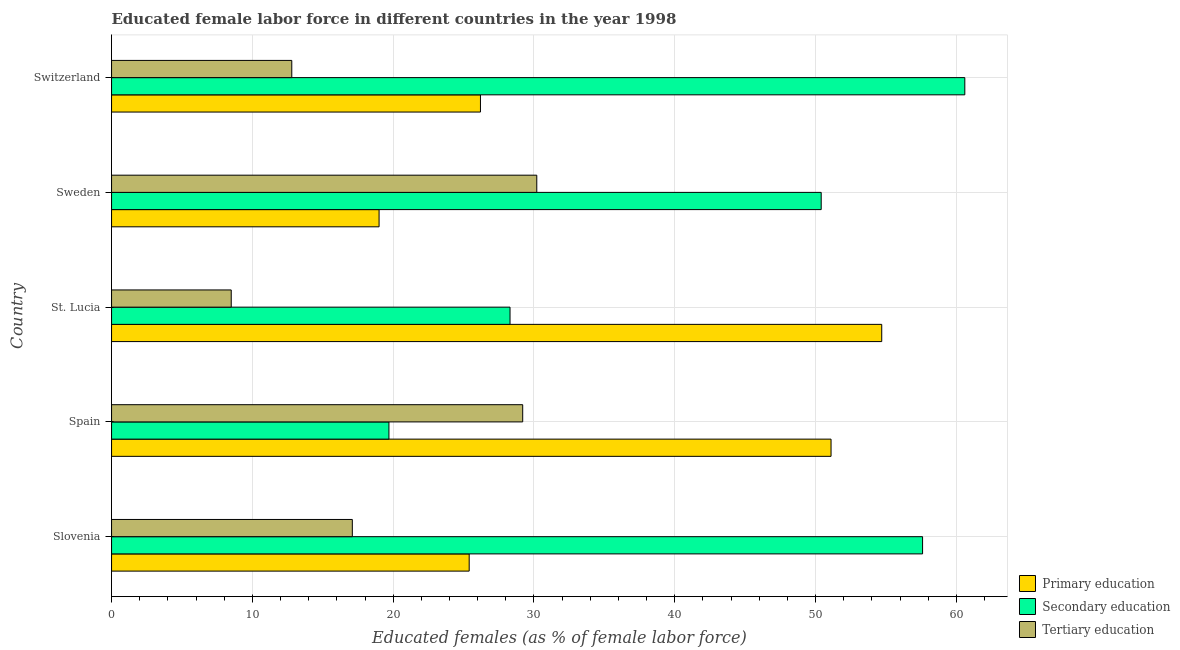How many different coloured bars are there?
Keep it short and to the point. 3. How many groups of bars are there?
Give a very brief answer. 5. Are the number of bars per tick equal to the number of legend labels?
Give a very brief answer. Yes. How many bars are there on the 5th tick from the top?
Your answer should be compact. 3. What is the label of the 3rd group of bars from the top?
Provide a short and direct response. St. Lucia. What is the percentage of female labor force who received primary education in St. Lucia?
Offer a very short reply. 54.7. Across all countries, what is the maximum percentage of female labor force who received secondary education?
Make the answer very short. 60.6. Across all countries, what is the minimum percentage of female labor force who received primary education?
Your response must be concise. 19. In which country was the percentage of female labor force who received primary education maximum?
Provide a short and direct response. St. Lucia. In which country was the percentage of female labor force who received secondary education minimum?
Provide a succinct answer. Spain. What is the total percentage of female labor force who received tertiary education in the graph?
Provide a succinct answer. 97.8. What is the difference between the percentage of female labor force who received secondary education in Sweden and that in Switzerland?
Ensure brevity in your answer.  -10.2. What is the difference between the percentage of female labor force who received primary education in Sweden and the percentage of female labor force who received secondary education in Switzerland?
Make the answer very short. -41.6. What is the average percentage of female labor force who received secondary education per country?
Your answer should be very brief. 43.32. What is the difference between the percentage of female labor force who received secondary education and percentage of female labor force who received primary education in Sweden?
Give a very brief answer. 31.4. In how many countries, is the percentage of female labor force who received tertiary education greater than 56 %?
Your answer should be very brief. 0. What is the ratio of the percentage of female labor force who received primary education in St. Lucia to that in Sweden?
Offer a terse response. 2.88. Is the difference between the percentage of female labor force who received tertiary education in Spain and Switzerland greater than the difference between the percentage of female labor force who received secondary education in Spain and Switzerland?
Provide a short and direct response. Yes. What is the difference between the highest and the lowest percentage of female labor force who received primary education?
Give a very brief answer. 35.7. In how many countries, is the percentage of female labor force who received tertiary education greater than the average percentage of female labor force who received tertiary education taken over all countries?
Keep it short and to the point. 2. Is the sum of the percentage of female labor force who received tertiary education in Spain and St. Lucia greater than the maximum percentage of female labor force who received secondary education across all countries?
Ensure brevity in your answer.  No. What does the 2nd bar from the bottom in Switzerland represents?
Give a very brief answer. Secondary education. Is it the case that in every country, the sum of the percentage of female labor force who received primary education and percentage of female labor force who received secondary education is greater than the percentage of female labor force who received tertiary education?
Provide a short and direct response. Yes. Are all the bars in the graph horizontal?
Provide a succinct answer. Yes. How many countries are there in the graph?
Give a very brief answer. 5. How are the legend labels stacked?
Provide a succinct answer. Vertical. What is the title of the graph?
Ensure brevity in your answer.  Educated female labor force in different countries in the year 1998. What is the label or title of the X-axis?
Your answer should be very brief. Educated females (as % of female labor force). What is the Educated females (as % of female labor force) in Primary education in Slovenia?
Your answer should be very brief. 25.4. What is the Educated females (as % of female labor force) of Secondary education in Slovenia?
Provide a short and direct response. 57.6. What is the Educated females (as % of female labor force) in Tertiary education in Slovenia?
Your answer should be compact. 17.1. What is the Educated females (as % of female labor force) of Primary education in Spain?
Offer a terse response. 51.1. What is the Educated females (as % of female labor force) of Secondary education in Spain?
Your answer should be compact. 19.7. What is the Educated females (as % of female labor force) in Tertiary education in Spain?
Keep it short and to the point. 29.2. What is the Educated females (as % of female labor force) of Primary education in St. Lucia?
Make the answer very short. 54.7. What is the Educated females (as % of female labor force) in Secondary education in St. Lucia?
Make the answer very short. 28.3. What is the Educated females (as % of female labor force) in Tertiary education in St. Lucia?
Ensure brevity in your answer.  8.5. What is the Educated females (as % of female labor force) in Secondary education in Sweden?
Offer a very short reply. 50.4. What is the Educated females (as % of female labor force) of Tertiary education in Sweden?
Keep it short and to the point. 30.2. What is the Educated females (as % of female labor force) of Primary education in Switzerland?
Your response must be concise. 26.2. What is the Educated females (as % of female labor force) of Secondary education in Switzerland?
Ensure brevity in your answer.  60.6. What is the Educated females (as % of female labor force) in Tertiary education in Switzerland?
Ensure brevity in your answer.  12.8. Across all countries, what is the maximum Educated females (as % of female labor force) of Primary education?
Provide a succinct answer. 54.7. Across all countries, what is the maximum Educated females (as % of female labor force) in Secondary education?
Your answer should be compact. 60.6. Across all countries, what is the maximum Educated females (as % of female labor force) of Tertiary education?
Give a very brief answer. 30.2. Across all countries, what is the minimum Educated females (as % of female labor force) in Primary education?
Your answer should be compact. 19. Across all countries, what is the minimum Educated females (as % of female labor force) of Secondary education?
Make the answer very short. 19.7. Across all countries, what is the minimum Educated females (as % of female labor force) of Tertiary education?
Keep it short and to the point. 8.5. What is the total Educated females (as % of female labor force) in Primary education in the graph?
Your answer should be very brief. 176.4. What is the total Educated females (as % of female labor force) in Secondary education in the graph?
Make the answer very short. 216.6. What is the total Educated females (as % of female labor force) in Tertiary education in the graph?
Offer a very short reply. 97.8. What is the difference between the Educated females (as % of female labor force) in Primary education in Slovenia and that in Spain?
Offer a very short reply. -25.7. What is the difference between the Educated females (as % of female labor force) of Secondary education in Slovenia and that in Spain?
Offer a very short reply. 37.9. What is the difference between the Educated females (as % of female labor force) of Tertiary education in Slovenia and that in Spain?
Offer a very short reply. -12.1. What is the difference between the Educated females (as % of female labor force) of Primary education in Slovenia and that in St. Lucia?
Your answer should be compact. -29.3. What is the difference between the Educated females (as % of female labor force) of Secondary education in Slovenia and that in St. Lucia?
Offer a terse response. 29.3. What is the difference between the Educated females (as % of female labor force) of Primary education in Slovenia and that in Sweden?
Keep it short and to the point. 6.4. What is the difference between the Educated females (as % of female labor force) of Tertiary education in Slovenia and that in Sweden?
Keep it short and to the point. -13.1. What is the difference between the Educated females (as % of female labor force) in Primary education in Slovenia and that in Switzerland?
Make the answer very short. -0.8. What is the difference between the Educated females (as % of female labor force) of Tertiary education in Slovenia and that in Switzerland?
Offer a very short reply. 4.3. What is the difference between the Educated females (as % of female labor force) in Primary education in Spain and that in St. Lucia?
Provide a succinct answer. -3.6. What is the difference between the Educated females (as % of female labor force) of Secondary education in Spain and that in St. Lucia?
Offer a very short reply. -8.6. What is the difference between the Educated females (as % of female labor force) of Tertiary education in Spain and that in St. Lucia?
Your response must be concise. 20.7. What is the difference between the Educated females (as % of female labor force) of Primary education in Spain and that in Sweden?
Offer a terse response. 32.1. What is the difference between the Educated females (as % of female labor force) of Secondary education in Spain and that in Sweden?
Your answer should be compact. -30.7. What is the difference between the Educated females (as % of female labor force) of Tertiary education in Spain and that in Sweden?
Keep it short and to the point. -1. What is the difference between the Educated females (as % of female labor force) of Primary education in Spain and that in Switzerland?
Ensure brevity in your answer.  24.9. What is the difference between the Educated females (as % of female labor force) in Secondary education in Spain and that in Switzerland?
Offer a terse response. -40.9. What is the difference between the Educated females (as % of female labor force) in Primary education in St. Lucia and that in Sweden?
Offer a very short reply. 35.7. What is the difference between the Educated females (as % of female labor force) in Secondary education in St. Lucia and that in Sweden?
Ensure brevity in your answer.  -22.1. What is the difference between the Educated females (as % of female labor force) in Tertiary education in St. Lucia and that in Sweden?
Give a very brief answer. -21.7. What is the difference between the Educated females (as % of female labor force) in Secondary education in St. Lucia and that in Switzerland?
Provide a succinct answer. -32.3. What is the difference between the Educated females (as % of female labor force) in Tertiary education in Sweden and that in Switzerland?
Ensure brevity in your answer.  17.4. What is the difference between the Educated females (as % of female labor force) of Secondary education in Slovenia and the Educated females (as % of female labor force) of Tertiary education in Spain?
Your answer should be compact. 28.4. What is the difference between the Educated females (as % of female labor force) in Secondary education in Slovenia and the Educated females (as % of female labor force) in Tertiary education in St. Lucia?
Your answer should be very brief. 49.1. What is the difference between the Educated females (as % of female labor force) of Secondary education in Slovenia and the Educated females (as % of female labor force) of Tertiary education in Sweden?
Provide a short and direct response. 27.4. What is the difference between the Educated females (as % of female labor force) in Primary education in Slovenia and the Educated females (as % of female labor force) in Secondary education in Switzerland?
Ensure brevity in your answer.  -35.2. What is the difference between the Educated females (as % of female labor force) in Secondary education in Slovenia and the Educated females (as % of female labor force) in Tertiary education in Switzerland?
Your answer should be very brief. 44.8. What is the difference between the Educated females (as % of female labor force) in Primary education in Spain and the Educated females (as % of female labor force) in Secondary education in St. Lucia?
Make the answer very short. 22.8. What is the difference between the Educated females (as % of female labor force) of Primary education in Spain and the Educated females (as % of female labor force) of Tertiary education in St. Lucia?
Give a very brief answer. 42.6. What is the difference between the Educated females (as % of female labor force) in Secondary education in Spain and the Educated females (as % of female labor force) in Tertiary education in St. Lucia?
Your answer should be compact. 11.2. What is the difference between the Educated females (as % of female labor force) in Primary education in Spain and the Educated females (as % of female labor force) in Secondary education in Sweden?
Your answer should be very brief. 0.7. What is the difference between the Educated females (as % of female labor force) in Primary education in Spain and the Educated females (as % of female labor force) in Tertiary education in Sweden?
Keep it short and to the point. 20.9. What is the difference between the Educated females (as % of female labor force) of Primary education in Spain and the Educated females (as % of female labor force) of Tertiary education in Switzerland?
Keep it short and to the point. 38.3. What is the difference between the Educated females (as % of female labor force) of Primary education in St. Lucia and the Educated females (as % of female labor force) of Secondary education in Sweden?
Offer a very short reply. 4.3. What is the difference between the Educated females (as % of female labor force) in Primary education in St. Lucia and the Educated females (as % of female labor force) in Secondary education in Switzerland?
Your answer should be compact. -5.9. What is the difference between the Educated females (as % of female labor force) of Primary education in St. Lucia and the Educated females (as % of female labor force) of Tertiary education in Switzerland?
Offer a very short reply. 41.9. What is the difference between the Educated females (as % of female labor force) of Secondary education in St. Lucia and the Educated females (as % of female labor force) of Tertiary education in Switzerland?
Your answer should be compact. 15.5. What is the difference between the Educated females (as % of female labor force) of Primary education in Sweden and the Educated females (as % of female labor force) of Secondary education in Switzerland?
Your response must be concise. -41.6. What is the difference between the Educated females (as % of female labor force) of Primary education in Sweden and the Educated females (as % of female labor force) of Tertiary education in Switzerland?
Your response must be concise. 6.2. What is the difference between the Educated females (as % of female labor force) of Secondary education in Sweden and the Educated females (as % of female labor force) of Tertiary education in Switzerland?
Your answer should be very brief. 37.6. What is the average Educated females (as % of female labor force) of Primary education per country?
Give a very brief answer. 35.28. What is the average Educated females (as % of female labor force) in Secondary education per country?
Give a very brief answer. 43.32. What is the average Educated females (as % of female labor force) of Tertiary education per country?
Your response must be concise. 19.56. What is the difference between the Educated females (as % of female labor force) in Primary education and Educated females (as % of female labor force) in Secondary education in Slovenia?
Ensure brevity in your answer.  -32.2. What is the difference between the Educated females (as % of female labor force) in Secondary education and Educated females (as % of female labor force) in Tertiary education in Slovenia?
Your answer should be compact. 40.5. What is the difference between the Educated females (as % of female labor force) of Primary education and Educated females (as % of female labor force) of Secondary education in Spain?
Your answer should be compact. 31.4. What is the difference between the Educated females (as % of female labor force) of Primary education and Educated females (as % of female labor force) of Tertiary education in Spain?
Make the answer very short. 21.9. What is the difference between the Educated females (as % of female labor force) of Secondary education and Educated females (as % of female labor force) of Tertiary education in Spain?
Ensure brevity in your answer.  -9.5. What is the difference between the Educated females (as % of female labor force) in Primary education and Educated females (as % of female labor force) in Secondary education in St. Lucia?
Your answer should be very brief. 26.4. What is the difference between the Educated females (as % of female labor force) in Primary education and Educated females (as % of female labor force) in Tertiary education in St. Lucia?
Provide a short and direct response. 46.2. What is the difference between the Educated females (as % of female labor force) in Secondary education and Educated females (as % of female labor force) in Tertiary education in St. Lucia?
Offer a terse response. 19.8. What is the difference between the Educated females (as % of female labor force) of Primary education and Educated females (as % of female labor force) of Secondary education in Sweden?
Your answer should be compact. -31.4. What is the difference between the Educated females (as % of female labor force) in Secondary education and Educated females (as % of female labor force) in Tertiary education in Sweden?
Give a very brief answer. 20.2. What is the difference between the Educated females (as % of female labor force) of Primary education and Educated females (as % of female labor force) of Secondary education in Switzerland?
Your answer should be very brief. -34.4. What is the difference between the Educated females (as % of female labor force) in Primary education and Educated females (as % of female labor force) in Tertiary education in Switzerland?
Your answer should be very brief. 13.4. What is the difference between the Educated females (as % of female labor force) in Secondary education and Educated females (as % of female labor force) in Tertiary education in Switzerland?
Your response must be concise. 47.8. What is the ratio of the Educated females (as % of female labor force) of Primary education in Slovenia to that in Spain?
Provide a short and direct response. 0.5. What is the ratio of the Educated females (as % of female labor force) in Secondary education in Slovenia to that in Spain?
Make the answer very short. 2.92. What is the ratio of the Educated females (as % of female labor force) in Tertiary education in Slovenia to that in Spain?
Provide a succinct answer. 0.59. What is the ratio of the Educated females (as % of female labor force) in Primary education in Slovenia to that in St. Lucia?
Offer a very short reply. 0.46. What is the ratio of the Educated females (as % of female labor force) of Secondary education in Slovenia to that in St. Lucia?
Ensure brevity in your answer.  2.04. What is the ratio of the Educated females (as % of female labor force) of Tertiary education in Slovenia to that in St. Lucia?
Provide a succinct answer. 2.01. What is the ratio of the Educated females (as % of female labor force) in Primary education in Slovenia to that in Sweden?
Provide a succinct answer. 1.34. What is the ratio of the Educated females (as % of female labor force) in Tertiary education in Slovenia to that in Sweden?
Offer a terse response. 0.57. What is the ratio of the Educated females (as % of female labor force) in Primary education in Slovenia to that in Switzerland?
Make the answer very short. 0.97. What is the ratio of the Educated females (as % of female labor force) in Secondary education in Slovenia to that in Switzerland?
Keep it short and to the point. 0.95. What is the ratio of the Educated females (as % of female labor force) in Tertiary education in Slovenia to that in Switzerland?
Give a very brief answer. 1.34. What is the ratio of the Educated females (as % of female labor force) of Primary education in Spain to that in St. Lucia?
Your answer should be compact. 0.93. What is the ratio of the Educated females (as % of female labor force) of Secondary education in Spain to that in St. Lucia?
Give a very brief answer. 0.7. What is the ratio of the Educated females (as % of female labor force) of Tertiary education in Spain to that in St. Lucia?
Your answer should be compact. 3.44. What is the ratio of the Educated females (as % of female labor force) of Primary education in Spain to that in Sweden?
Your answer should be compact. 2.69. What is the ratio of the Educated females (as % of female labor force) of Secondary education in Spain to that in Sweden?
Your answer should be compact. 0.39. What is the ratio of the Educated females (as % of female labor force) in Tertiary education in Spain to that in Sweden?
Offer a very short reply. 0.97. What is the ratio of the Educated females (as % of female labor force) in Primary education in Spain to that in Switzerland?
Offer a very short reply. 1.95. What is the ratio of the Educated females (as % of female labor force) of Secondary education in Spain to that in Switzerland?
Offer a terse response. 0.33. What is the ratio of the Educated females (as % of female labor force) in Tertiary education in Spain to that in Switzerland?
Make the answer very short. 2.28. What is the ratio of the Educated females (as % of female labor force) of Primary education in St. Lucia to that in Sweden?
Your answer should be compact. 2.88. What is the ratio of the Educated females (as % of female labor force) of Secondary education in St. Lucia to that in Sweden?
Provide a succinct answer. 0.56. What is the ratio of the Educated females (as % of female labor force) in Tertiary education in St. Lucia to that in Sweden?
Give a very brief answer. 0.28. What is the ratio of the Educated females (as % of female labor force) of Primary education in St. Lucia to that in Switzerland?
Provide a short and direct response. 2.09. What is the ratio of the Educated females (as % of female labor force) of Secondary education in St. Lucia to that in Switzerland?
Keep it short and to the point. 0.47. What is the ratio of the Educated females (as % of female labor force) of Tertiary education in St. Lucia to that in Switzerland?
Your response must be concise. 0.66. What is the ratio of the Educated females (as % of female labor force) of Primary education in Sweden to that in Switzerland?
Your response must be concise. 0.73. What is the ratio of the Educated females (as % of female labor force) of Secondary education in Sweden to that in Switzerland?
Provide a short and direct response. 0.83. What is the ratio of the Educated females (as % of female labor force) in Tertiary education in Sweden to that in Switzerland?
Offer a very short reply. 2.36. What is the difference between the highest and the second highest Educated females (as % of female labor force) in Secondary education?
Ensure brevity in your answer.  3. What is the difference between the highest and the lowest Educated females (as % of female labor force) in Primary education?
Provide a succinct answer. 35.7. What is the difference between the highest and the lowest Educated females (as % of female labor force) of Secondary education?
Offer a very short reply. 40.9. What is the difference between the highest and the lowest Educated females (as % of female labor force) in Tertiary education?
Your answer should be very brief. 21.7. 